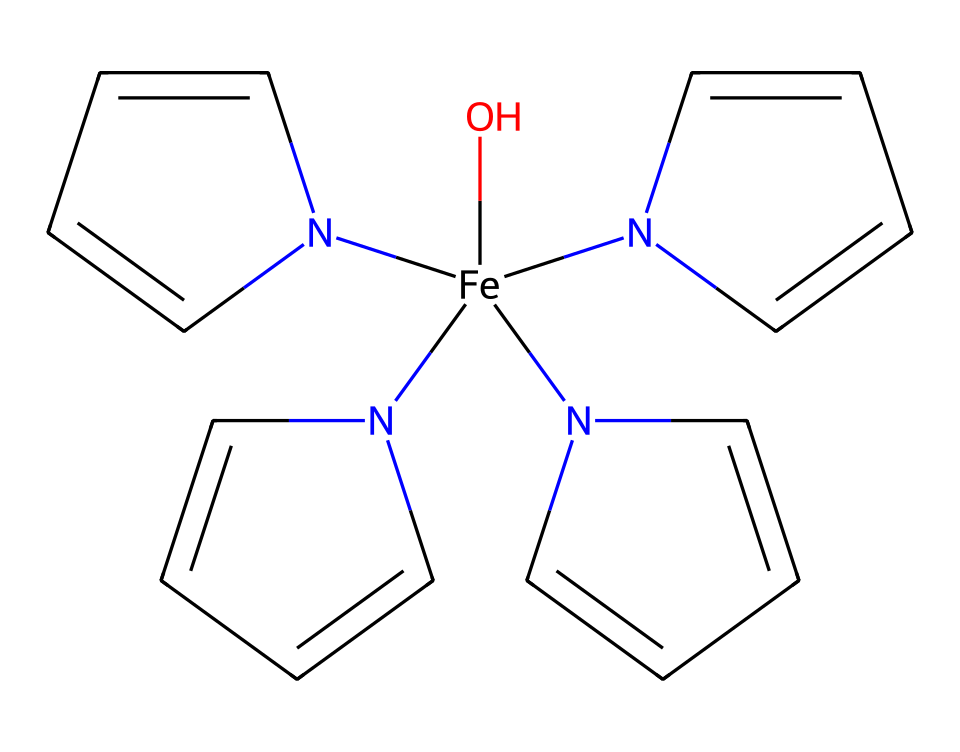What is the central metal atom in this coordination complex? The chemical structure shows an iron atom (Fe) in the center, surrounded by nitrogen-rich bases, indicating that it serves as the central metal in the coordination compound.
Answer: iron How many nitrogen atoms are present in this coordination compound? By inspecting the SMILES representation, there are four nitrogen atoms (N) directly bonded to the iron atom, which are part of the ligands around it.
Answer: four What type of ligands are coordinated to the central metal? The structure consists of various nitrogen-containing rings (as indicated by the 'N' attached to aromatic carbons), making them amine ligands or nitrogen donor ligands, typical of complex formation with metals.
Answer: nitrogen ligands What does the presence of the hydroxyl group indicate about this compound? The hydroxyl group (O) in the compound suggests possible reactivity and solubility in aqueous environments, and it can improve binding and stability in biological systems, particularly for oxygen transport.
Answer: reactivity How does the structure of hemoglobin relate to its function in oxygen transport? The coordination complex has iron at its center, crucial for binding oxygen molecules (O2), and the arrangement of ligands facilitates the reversible binding of oxygen, enabling efficient transport in the bloodstream.
Answer: oxygen transport 